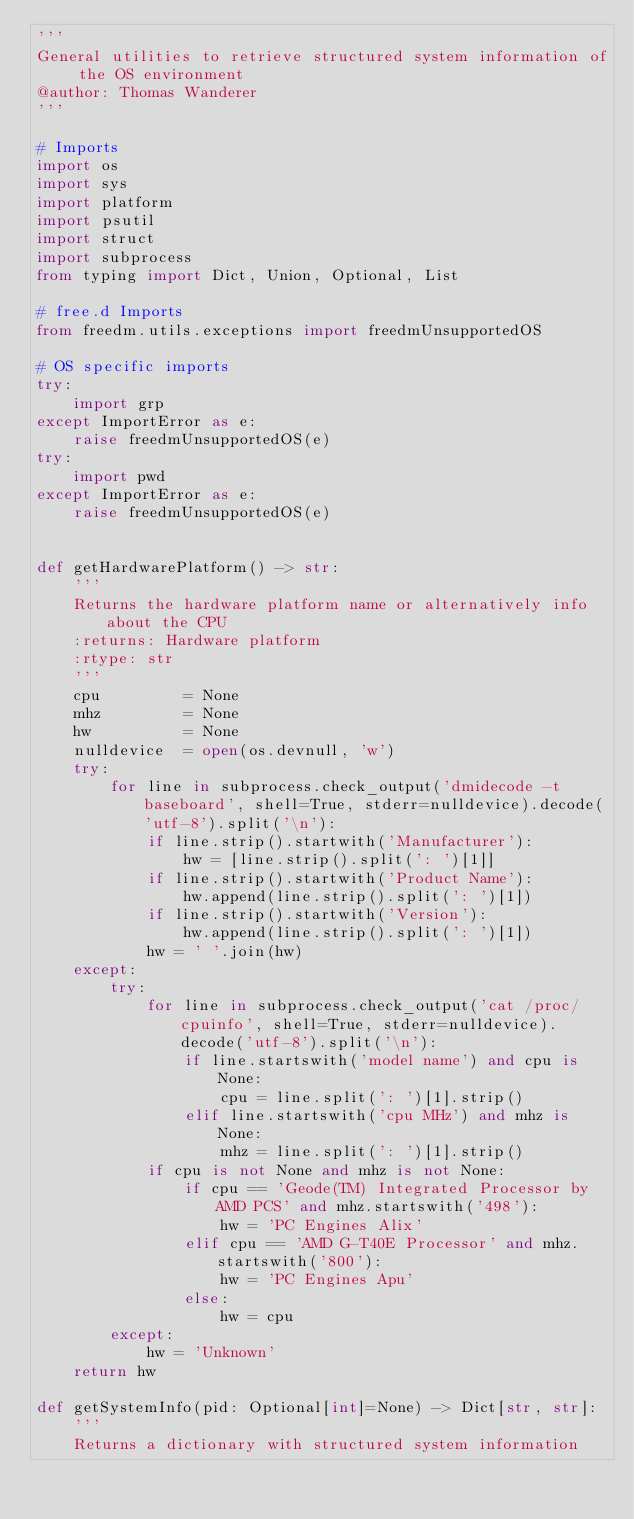Convert code to text. <code><loc_0><loc_0><loc_500><loc_500><_Python_>'''
General utilities to retrieve structured system information of the OS environment
@author: Thomas Wanderer
'''

# Imports
import os
import sys
import platform
import psutil
import struct
import subprocess
from typing import Dict, Union, Optional, List

# free.d Imports
from freedm.utils.exceptions import freedmUnsupportedOS

# OS specific imports
try:
    import grp
except ImportError as e:
    raise freedmUnsupportedOS(e)
try:
    import pwd
except ImportError as e:
    raise freedmUnsupportedOS(e)


def getHardwarePlatform() -> str:
    '''
    Returns the hardware platform name or alternatively info about the CPU
    :returns: Hardware platform
    :rtype: str
    '''
    cpu         = None
    mhz         = None
    hw          = None
    nulldevice  = open(os.devnull, 'w')
    try:
        for line in subprocess.check_output('dmidecode -t baseboard', shell=True, stderr=nulldevice).decode('utf-8').split('\n'):
            if line.strip().startwith('Manufacturer'):
                hw = [line.strip().split(': ')[1]]
            if line.strip().startwith('Product Name'):
                hw.append(line.strip().split(': ')[1])
            if line.strip().startwith('Version'):
                hw.append(line.strip().split(': ')[1])
            hw = ' '.join(hw)
    except:
        try:
            for line in subprocess.check_output('cat /proc/cpuinfo', shell=True, stderr=nulldevice).decode('utf-8').split('\n'):
                if line.startswith('model name') and cpu is None:
                    cpu = line.split(': ')[1].strip()
                elif line.startswith('cpu MHz') and mhz is None:
                    mhz = line.split(': ')[1].strip()
            if cpu is not None and mhz is not None:
                if cpu == 'Geode(TM) Integrated Processor by AMD PCS' and mhz.startswith('498'):
                    hw = 'PC Engines Alix'
                elif cpu == 'AMD G-T40E Processor' and mhz.startswith('800'):
                    hw = 'PC Engines Apu'
                else:
                    hw = cpu
        except:
            hw = 'Unknown'
    return hw

def getSystemInfo(pid: Optional[int]=None) -> Dict[str, str]:
    '''
    Returns a dictionary with structured system information</code> 